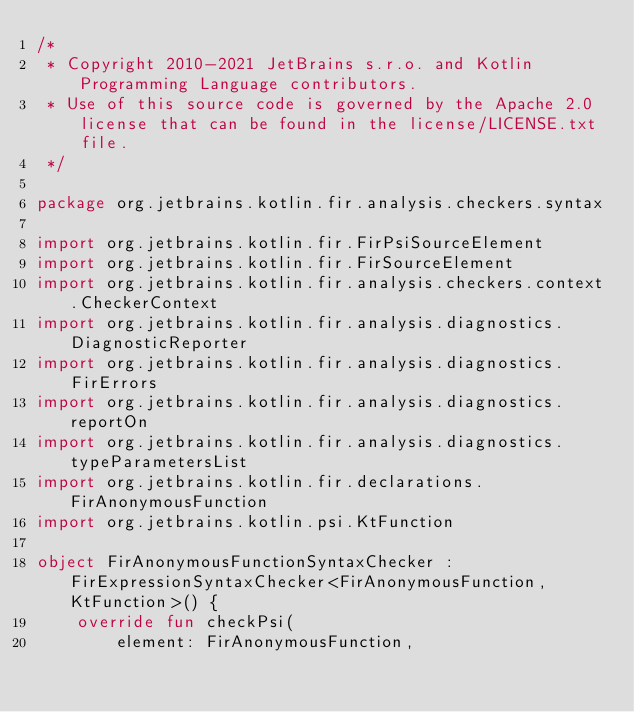Convert code to text. <code><loc_0><loc_0><loc_500><loc_500><_Kotlin_>/*
 * Copyright 2010-2021 JetBrains s.r.o. and Kotlin Programming Language contributors.
 * Use of this source code is governed by the Apache 2.0 license that can be found in the license/LICENSE.txt file.
 */

package org.jetbrains.kotlin.fir.analysis.checkers.syntax

import org.jetbrains.kotlin.fir.FirPsiSourceElement
import org.jetbrains.kotlin.fir.FirSourceElement
import org.jetbrains.kotlin.fir.analysis.checkers.context.CheckerContext
import org.jetbrains.kotlin.fir.analysis.diagnostics.DiagnosticReporter
import org.jetbrains.kotlin.fir.analysis.diagnostics.FirErrors
import org.jetbrains.kotlin.fir.analysis.diagnostics.reportOn
import org.jetbrains.kotlin.fir.analysis.diagnostics.typeParametersList
import org.jetbrains.kotlin.fir.declarations.FirAnonymousFunction
import org.jetbrains.kotlin.psi.KtFunction

object FirAnonymousFunctionSyntaxChecker : FirExpressionSyntaxChecker<FirAnonymousFunction, KtFunction>() {
    override fun checkPsi(
        element: FirAnonymousFunction,</code> 